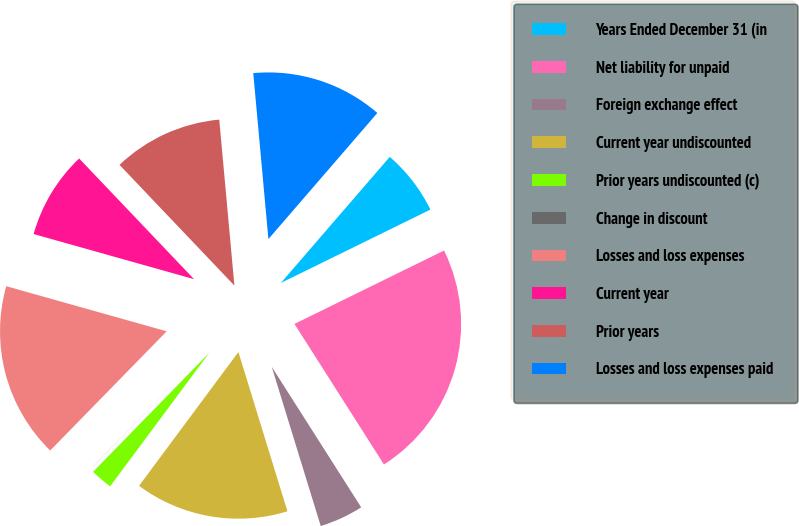<chart> <loc_0><loc_0><loc_500><loc_500><pie_chart><fcel>Years Ended December 31 (in<fcel>Net liability for unpaid<fcel>Foreign exchange effect<fcel>Current year undiscounted<fcel>Prior years undiscounted (c)<fcel>Change in discount<fcel>Losses and loss expenses<fcel>Current year<fcel>Prior years<fcel>Losses and loss expenses paid<nl><fcel>6.4%<fcel>23.24%<fcel>4.27%<fcel>14.92%<fcel>2.14%<fcel>0.01%<fcel>17.05%<fcel>8.53%<fcel>10.66%<fcel>12.79%<nl></chart> 